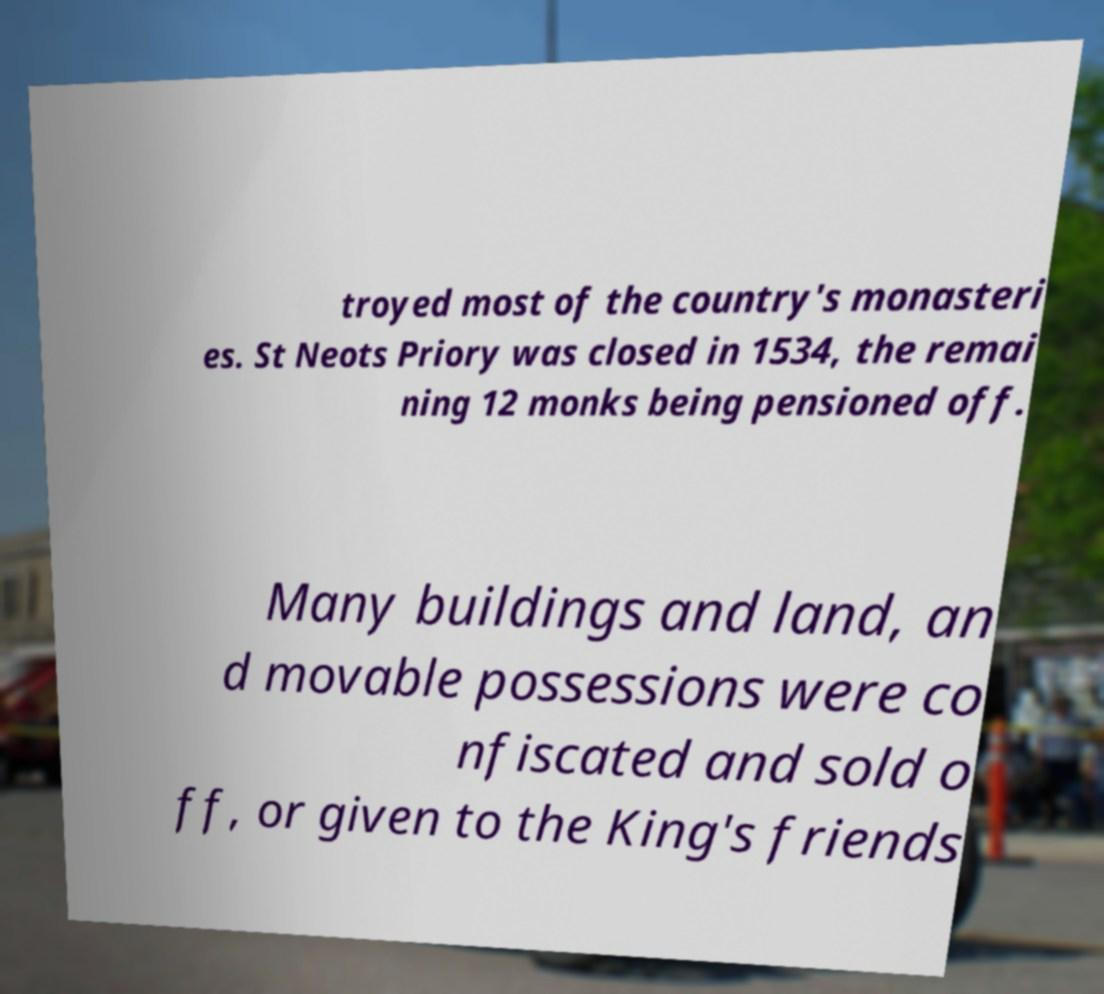There's text embedded in this image that I need extracted. Can you transcribe it verbatim? troyed most of the country's monasteri es. St Neots Priory was closed in 1534, the remai ning 12 monks being pensioned off. Many buildings and land, an d movable possessions were co nfiscated and sold o ff, or given to the King's friends 